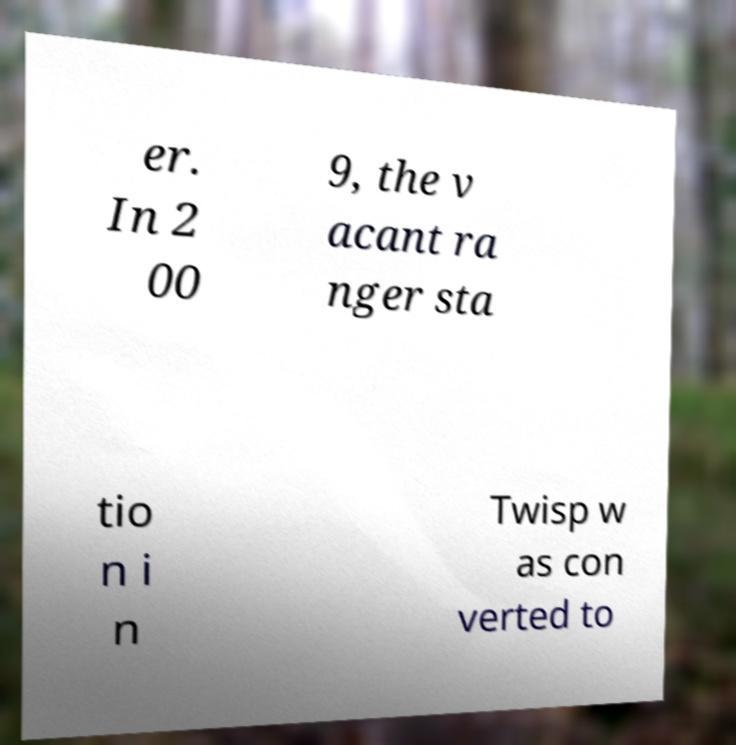Please identify and transcribe the text found in this image. er. In 2 00 9, the v acant ra nger sta tio n i n Twisp w as con verted to 